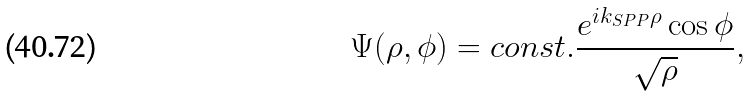Convert formula to latex. <formula><loc_0><loc_0><loc_500><loc_500>\Psi ( \rho , \phi ) = c o n s t . \frac { e ^ { i k _ { S P P } \rho } \cos { \phi } } { \sqrt { \rho } } ,</formula> 